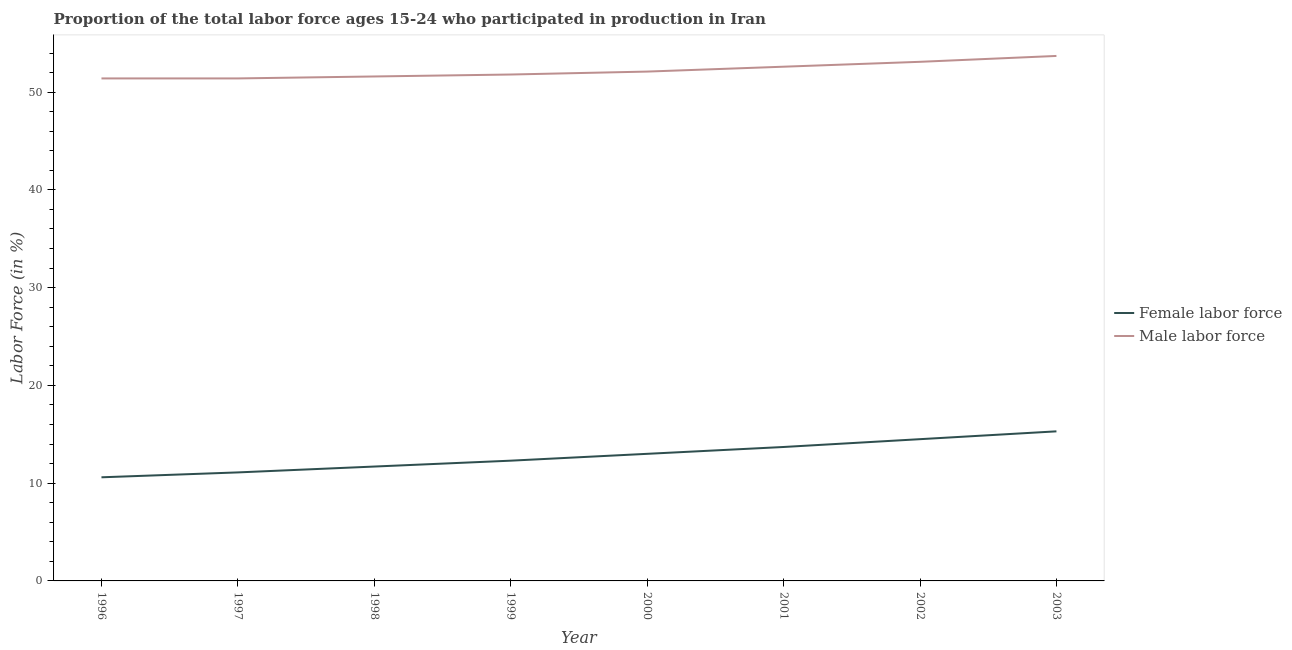Is the number of lines equal to the number of legend labels?
Offer a terse response. Yes. What is the percentage of female labor force in 1996?
Your answer should be very brief. 10.6. Across all years, what is the maximum percentage of male labour force?
Give a very brief answer. 53.7. Across all years, what is the minimum percentage of female labor force?
Offer a very short reply. 10.6. In which year was the percentage of female labor force maximum?
Ensure brevity in your answer.  2003. In which year was the percentage of male labour force minimum?
Your answer should be very brief. 1996. What is the total percentage of male labour force in the graph?
Offer a very short reply. 417.7. What is the difference between the percentage of male labour force in 1998 and the percentage of female labor force in 2001?
Provide a short and direct response. 37.9. What is the average percentage of female labor force per year?
Your answer should be very brief. 12.78. In the year 2000, what is the difference between the percentage of male labour force and percentage of female labor force?
Your answer should be very brief. 39.1. In how many years, is the percentage of male labour force greater than 50 %?
Provide a short and direct response. 8. What is the ratio of the percentage of male labour force in 1997 to that in 1998?
Give a very brief answer. 1. What is the difference between the highest and the second highest percentage of male labour force?
Provide a short and direct response. 0.6. What is the difference between the highest and the lowest percentage of female labor force?
Your answer should be compact. 4.7. How many lines are there?
Your answer should be compact. 2. How many years are there in the graph?
Your answer should be very brief. 8. What is the difference between two consecutive major ticks on the Y-axis?
Make the answer very short. 10. Are the values on the major ticks of Y-axis written in scientific E-notation?
Provide a short and direct response. No. Does the graph contain any zero values?
Keep it short and to the point. No. Where does the legend appear in the graph?
Ensure brevity in your answer.  Center right. How many legend labels are there?
Ensure brevity in your answer.  2. How are the legend labels stacked?
Your answer should be very brief. Vertical. What is the title of the graph?
Ensure brevity in your answer.  Proportion of the total labor force ages 15-24 who participated in production in Iran. Does "current US$" appear as one of the legend labels in the graph?
Make the answer very short. No. What is the Labor Force (in %) in Female labor force in 1996?
Provide a succinct answer. 10.6. What is the Labor Force (in %) of Male labor force in 1996?
Your response must be concise. 51.4. What is the Labor Force (in %) of Female labor force in 1997?
Your response must be concise. 11.1. What is the Labor Force (in %) of Male labor force in 1997?
Give a very brief answer. 51.4. What is the Labor Force (in %) in Female labor force in 1998?
Keep it short and to the point. 11.7. What is the Labor Force (in %) in Male labor force in 1998?
Give a very brief answer. 51.6. What is the Labor Force (in %) in Female labor force in 1999?
Ensure brevity in your answer.  12.3. What is the Labor Force (in %) of Male labor force in 1999?
Offer a terse response. 51.8. What is the Labor Force (in %) in Male labor force in 2000?
Offer a terse response. 52.1. What is the Labor Force (in %) in Female labor force in 2001?
Your answer should be very brief. 13.7. What is the Labor Force (in %) in Male labor force in 2001?
Make the answer very short. 52.6. What is the Labor Force (in %) in Female labor force in 2002?
Offer a terse response. 14.5. What is the Labor Force (in %) in Male labor force in 2002?
Keep it short and to the point. 53.1. What is the Labor Force (in %) of Female labor force in 2003?
Give a very brief answer. 15.3. What is the Labor Force (in %) in Male labor force in 2003?
Offer a terse response. 53.7. Across all years, what is the maximum Labor Force (in %) in Female labor force?
Ensure brevity in your answer.  15.3. Across all years, what is the maximum Labor Force (in %) of Male labor force?
Ensure brevity in your answer.  53.7. Across all years, what is the minimum Labor Force (in %) of Female labor force?
Ensure brevity in your answer.  10.6. Across all years, what is the minimum Labor Force (in %) in Male labor force?
Offer a very short reply. 51.4. What is the total Labor Force (in %) of Female labor force in the graph?
Give a very brief answer. 102.2. What is the total Labor Force (in %) of Male labor force in the graph?
Your answer should be very brief. 417.7. What is the difference between the Labor Force (in %) in Female labor force in 1996 and that in 1998?
Provide a succinct answer. -1.1. What is the difference between the Labor Force (in %) of Male labor force in 1996 and that in 1998?
Your answer should be very brief. -0.2. What is the difference between the Labor Force (in %) of Male labor force in 1996 and that in 1999?
Make the answer very short. -0.4. What is the difference between the Labor Force (in %) of Female labor force in 1996 and that in 2000?
Give a very brief answer. -2.4. What is the difference between the Labor Force (in %) in Male labor force in 1996 and that in 2000?
Your answer should be compact. -0.7. What is the difference between the Labor Force (in %) in Male labor force in 1997 and that in 1998?
Give a very brief answer. -0.2. What is the difference between the Labor Force (in %) in Female labor force in 1997 and that in 2000?
Give a very brief answer. -1.9. What is the difference between the Labor Force (in %) in Female labor force in 1997 and that in 2003?
Your answer should be very brief. -4.2. What is the difference between the Labor Force (in %) in Female labor force in 1998 and that in 2000?
Provide a short and direct response. -1.3. What is the difference between the Labor Force (in %) of Female labor force in 1998 and that in 2001?
Provide a short and direct response. -2. What is the difference between the Labor Force (in %) in Male labor force in 1998 and that in 2001?
Make the answer very short. -1. What is the difference between the Labor Force (in %) of Female labor force in 1998 and that in 2002?
Keep it short and to the point. -2.8. What is the difference between the Labor Force (in %) of Male labor force in 1998 and that in 2002?
Make the answer very short. -1.5. What is the difference between the Labor Force (in %) of Female labor force in 1998 and that in 2003?
Offer a terse response. -3.6. What is the difference between the Labor Force (in %) in Female labor force in 1999 and that in 2000?
Keep it short and to the point. -0.7. What is the difference between the Labor Force (in %) of Male labor force in 1999 and that in 2000?
Make the answer very short. -0.3. What is the difference between the Labor Force (in %) in Female labor force in 1999 and that in 2002?
Give a very brief answer. -2.2. What is the difference between the Labor Force (in %) of Female labor force in 1999 and that in 2003?
Offer a very short reply. -3. What is the difference between the Labor Force (in %) of Male labor force in 1999 and that in 2003?
Provide a succinct answer. -1.9. What is the difference between the Labor Force (in %) of Female labor force in 2000 and that in 2002?
Your answer should be very brief. -1.5. What is the difference between the Labor Force (in %) of Male labor force in 2000 and that in 2003?
Offer a terse response. -1.6. What is the difference between the Labor Force (in %) in Female labor force in 2001 and that in 2002?
Your answer should be very brief. -0.8. What is the difference between the Labor Force (in %) in Male labor force in 2001 and that in 2002?
Offer a very short reply. -0.5. What is the difference between the Labor Force (in %) of Female labor force in 2001 and that in 2003?
Give a very brief answer. -1.6. What is the difference between the Labor Force (in %) in Male labor force in 2001 and that in 2003?
Make the answer very short. -1.1. What is the difference between the Labor Force (in %) in Female labor force in 1996 and the Labor Force (in %) in Male labor force in 1997?
Give a very brief answer. -40.8. What is the difference between the Labor Force (in %) in Female labor force in 1996 and the Labor Force (in %) in Male labor force in 1998?
Give a very brief answer. -41. What is the difference between the Labor Force (in %) in Female labor force in 1996 and the Labor Force (in %) in Male labor force in 1999?
Ensure brevity in your answer.  -41.2. What is the difference between the Labor Force (in %) of Female labor force in 1996 and the Labor Force (in %) of Male labor force in 2000?
Offer a terse response. -41.5. What is the difference between the Labor Force (in %) of Female labor force in 1996 and the Labor Force (in %) of Male labor force in 2001?
Your answer should be very brief. -42. What is the difference between the Labor Force (in %) in Female labor force in 1996 and the Labor Force (in %) in Male labor force in 2002?
Give a very brief answer. -42.5. What is the difference between the Labor Force (in %) of Female labor force in 1996 and the Labor Force (in %) of Male labor force in 2003?
Your response must be concise. -43.1. What is the difference between the Labor Force (in %) of Female labor force in 1997 and the Labor Force (in %) of Male labor force in 1998?
Your response must be concise. -40.5. What is the difference between the Labor Force (in %) of Female labor force in 1997 and the Labor Force (in %) of Male labor force in 1999?
Keep it short and to the point. -40.7. What is the difference between the Labor Force (in %) in Female labor force in 1997 and the Labor Force (in %) in Male labor force in 2000?
Your answer should be very brief. -41. What is the difference between the Labor Force (in %) in Female labor force in 1997 and the Labor Force (in %) in Male labor force in 2001?
Keep it short and to the point. -41.5. What is the difference between the Labor Force (in %) of Female labor force in 1997 and the Labor Force (in %) of Male labor force in 2002?
Keep it short and to the point. -42. What is the difference between the Labor Force (in %) in Female labor force in 1997 and the Labor Force (in %) in Male labor force in 2003?
Your answer should be very brief. -42.6. What is the difference between the Labor Force (in %) in Female labor force in 1998 and the Labor Force (in %) in Male labor force in 1999?
Make the answer very short. -40.1. What is the difference between the Labor Force (in %) in Female labor force in 1998 and the Labor Force (in %) in Male labor force in 2000?
Offer a terse response. -40.4. What is the difference between the Labor Force (in %) of Female labor force in 1998 and the Labor Force (in %) of Male labor force in 2001?
Provide a succinct answer. -40.9. What is the difference between the Labor Force (in %) of Female labor force in 1998 and the Labor Force (in %) of Male labor force in 2002?
Provide a short and direct response. -41.4. What is the difference between the Labor Force (in %) in Female labor force in 1998 and the Labor Force (in %) in Male labor force in 2003?
Keep it short and to the point. -42. What is the difference between the Labor Force (in %) of Female labor force in 1999 and the Labor Force (in %) of Male labor force in 2000?
Provide a short and direct response. -39.8. What is the difference between the Labor Force (in %) of Female labor force in 1999 and the Labor Force (in %) of Male labor force in 2001?
Provide a succinct answer. -40.3. What is the difference between the Labor Force (in %) of Female labor force in 1999 and the Labor Force (in %) of Male labor force in 2002?
Make the answer very short. -40.8. What is the difference between the Labor Force (in %) in Female labor force in 1999 and the Labor Force (in %) in Male labor force in 2003?
Keep it short and to the point. -41.4. What is the difference between the Labor Force (in %) of Female labor force in 2000 and the Labor Force (in %) of Male labor force in 2001?
Offer a terse response. -39.6. What is the difference between the Labor Force (in %) in Female labor force in 2000 and the Labor Force (in %) in Male labor force in 2002?
Offer a terse response. -40.1. What is the difference between the Labor Force (in %) in Female labor force in 2000 and the Labor Force (in %) in Male labor force in 2003?
Give a very brief answer. -40.7. What is the difference between the Labor Force (in %) of Female labor force in 2001 and the Labor Force (in %) of Male labor force in 2002?
Offer a very short reply. -39.4. What is the difference between the Labor Force (in %) of Female labor force in 2002 and the Labor Force (in %) of Male labor force in 2003?
Your response must be concise. -39.2. What is the average Labor Force (in %) in Female labor force per year?
Your answer should be very brief. 12.78. What is the average Labor Force (in %) of Male labor force per year?
Offer a very short reply. 52.21. In the year 1996, what is the difference between the Labor Force (in %) in Female labor force and Labor Force (in %) in Male labor force?
Offer a terse response. -40.8. In the year 1997, what is the difference between the Labor Force (in %) in Female labor force and Labor Force (in %) in Male labor force?
Keep it short and to the point. -40.3. In the year 1998, what is the difference between the Labor Force (in %) of Female labor force and Labor Force (in %) of Male labor force?
Provide a short and direct response. -39.9. In the year 1999, what is the difference between the Labor Force (in %) of Female labor force and Labor Force (in %) of Male labor force?
Ensure brevity in your answer.  -39.5. In the year 2000, what is the difference between the Labor Force (in %) of Female labor force and Labor Force (in %) of Male labor force?
Ensure brevity in your answer.  -39.1. In the year 2001, what is the difference between the Labor Force (in %) in Female labor force and Labor Force (in %) in Male labor force?
Provide a succinct answer. -38.9. In the year 2002, what is the difference between the Labor Force (in %) in Female labor force and Labor Force (in %) in Male labor force?
Provide a succinct answer. -38.6. In the year 2003, what is the difference between the Labor Force (in %) in Female labor force and Labor Force (in %) in Male labor force?
Provide a succinct answer. -38.4. What is the ratio of the Labor Force (in %) in Female labor force in 1996 to that in 1997?
Provide a short and direct response. 0.95. What is the ratio of the Labor Force (in %) of Female labor force in 1996 to that in 1998?
Provide a succinct answer. 0.91. What is the ratio of the Labor Force (in %) in Female labor force in 1996 to that in 1999?
Your answer should be very brief. 0.86. What is the ratio of the Labor Force (in %) in Female labor force in 1996 to that in 2000?
Offer a very short reply. 0.82. What is the ratio of the Labor Force (in %) of Male labor force in 1996 to that in 2000?
Keep it short and to the point. 0.99. What is the ratio of the Labor Force (in %) of Female labor force in 1996 to that in 2001?
Offer a terse response. 0.77. What is the ratio of the Labor Force (in %) in Male labor force in 1996 to that in 2001?
Make the answer very short. 0.98. What is the ratio of the Labor Force (in %) in Female labor force in 1996 to that in 2002?
Provide a short and direct response. 0.73. What is the ratio of the Labor Force (in %) of Female labor force in 1996 to that in 2003?
Offer a terse response. 0.69. What is the ratio of the Labor Force (in %) of Male labor force in 1996 to that in 2003?
Make the answer very short. 0.96. What is the ratio of the Labor Force (in %) of Female labor force in 1997 to that in 1998?
Provide a succinct answer. 0.95. What is the ratio of the Labor Force (in %) of Female labor force in 1997 to that in 1999?
Provide a short and direct response. 0.9. What is the ratio of the Labor Force (in %) in Female labor force in 1997 to that in 2000?
Keep it short and to the point. 0.85. What is the ratio of the Labor Force (in %) in Male labor force in 1997 to that in 2000?
Your answer should be very brief. 0.99. What is the ratio of the Labor Force (in %) of Female labor force in 1997 to that in 2001?
Make the answer very short. 0.81. What is the ratio of the Labor Force (in %) in Male labor force in 1997 to that in 2001?
Offer a very short reply. 0.98. What is the ratio of the Labor Force (in %) in Female labor force in 1997 to that in 2002?
Ensure brevity in your answer.  0.77. What is the ratio of the Labor Force (in %) in Male labor force in 1997 to that in 2002?
Make the answer very short. 0.97. What is the ratio of the Labor Force (in %) of Female labor force in 1997 to that in 2003?
Your answer should be compact. 0.73. What is the ratio of the Labor Force (in %) of Male labor force in 1997 to that in 2003?
Ensure brevity in your answer.  0.96. What is the ratio of the Labor Force (in %) of Female labor force in 1998 to that in 1999?
Offer a very short reply. 0.95. What is the ratio of the Labor Force (in %) in Male labor force in 1998 to that in 1999?
Give a very brief answer. 1. What is the ratio of the Labor Force (in %) of Male labor force in 1998 to that in 2000?
Make the answer very short. 0.99. What is the ratio of the Labor Force (in %) in Female labor force in 1998 to that in 2001?
Keep it short and to the point. 0.85. What is the ratio of the Labor Force (in %) in Female labor force in 1998 to that in 2002?
Ensure brevity in your answer.  0.81. What is the ratio of the Labor Force (in %) of Male labor force in 1998 to that in 2002?
Your answer should be very brief. 0.97. What is the ratio of the Labor Force (in %) in Female labor force in 1998 to that in 2003?
Your answer should be compact. 0.76. What is the ratio of the Labor Force (in %) in Male labor force in 1998 to that in 2003?
Give a very brief answer. 0.96. What is the ratio of the Labor Force (in %) of Female labor force in 1999 to that in 2000?
Keep it short and to the point. 0.95. What is the ratio of the Labor Force (in %) in Male labor force in 1999 to that in 2000?
Offer a terse response. 0.99. What is the ratio of the Labor Force (in %) of Female labor force in 1999 to that in 2001?
Give a very brief answer. 0.9. What is the ratio of the Labor Force (in %) in Female labor force in 1999 to that in 2002?
Your answer should be very brief. 0.85. What is the ratio of the Labor Force (in %) in Male labor force in 1999 to that in 2002?
Provide a succinct answer. 0.98. What is the ratio of the Labor Force (in %) of Female labor force in 1999 to that in 2003?
Make the answer very short. 0.8. What is the ratio of the Labor Force (in %) in Male labor force in 1999 to that in 2003?
Your answer should be compact. 0.96. What is the ratio of the Labor Force (in %) in Female labor force in 2000 to that in 2001?
Your response must be concise. 0.95. What is the ratio of the Labor Force (in %) in Male labor force in 2000 to that in 2001?
Give a very brief answer. 0.99. What is the ratio of the Labor Force (in %) of Female labor force in 2000 to that in 2002?
Your answer should be very brief. 0.9. What is the ratio of the Labor Force (in %) of Male labor force in 2000 to that in 2002?
Give a very brief answer. 0.98. What is the ratio of the Labor Force (in %) in Female labor force in 2000 to that in 2003?
Provide a short and direct response. 0.85. What is the ratio of the Labor Force (in %) in Male labor force in 2000 to that in 2003?
Your answer should be very brief. 0.97. What is the ratio of the Labor Force (in %) of Female labor force in 2001 to that in 2002?
Provide a short and direct response. 0.94. What is the ratio of the Labor Force (in %) in Male labor force in 2001 to that in 2002?
Ensure brevity in your answer.  0.99. What is the ratio of the Labor Force (in %) in Female labor force in 2001 to that in 2003?
Offer a terse response. 0.9. What is the ratio of the Labor Force (in %) of Male labor force in 2001 to that in 2003?
Keep it short and to the point. 0.98. What is the ratio of the Labor Force (in %) of Female labor force in 2002 to that in 2003?
Your answer should be very brief. 0.95. 